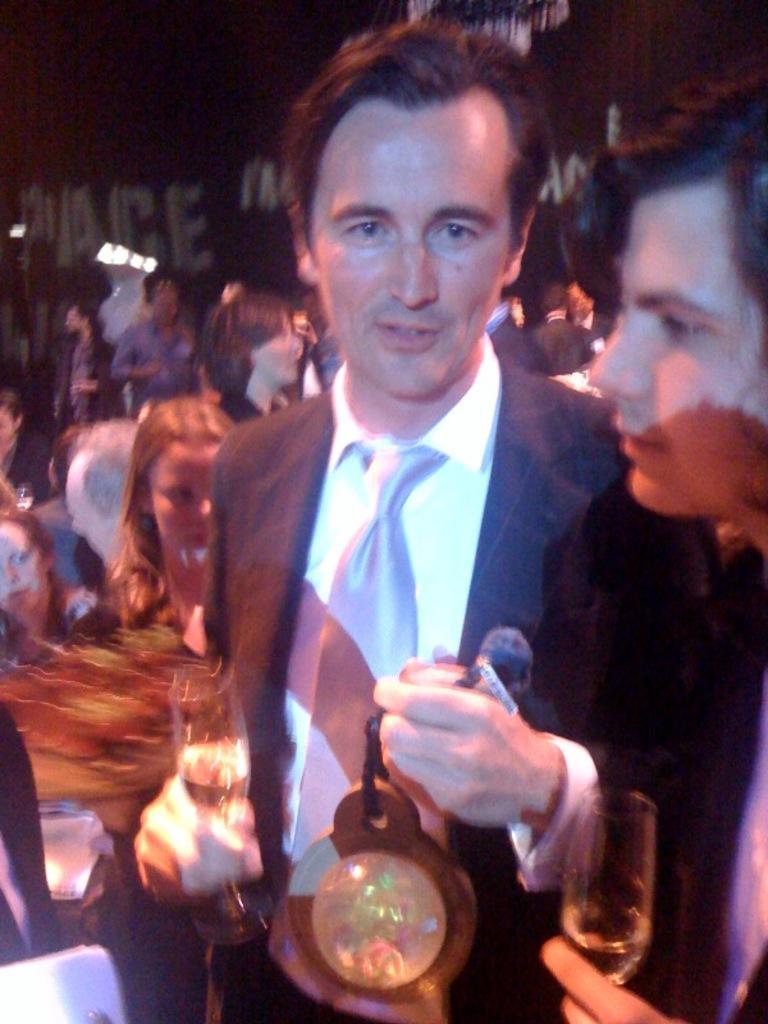Please provide a concise description of this image. In this picture I can see few people standing and few of them holding glasses in their hands and I can see a man holding a fancy ball in another hand. 